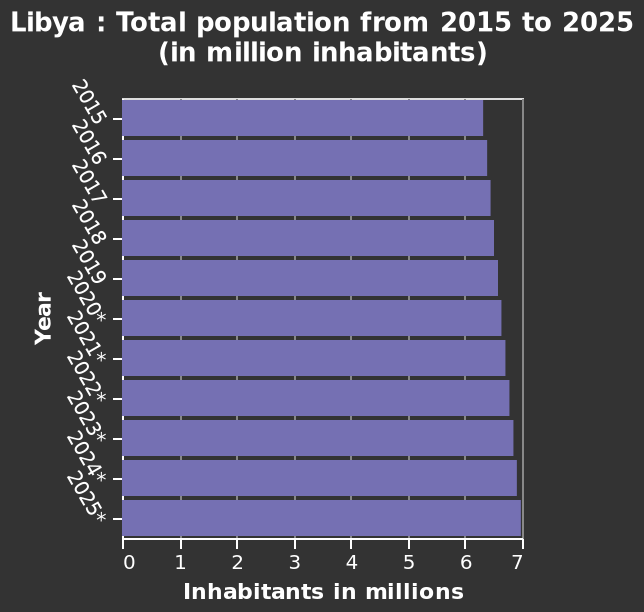<image>
please enumerates aspects of the construction of the chart Here a is a bar chart called Libya : Total population from 2015 to 2025 (in million inhabitants). Along the y-axis, Year is defined along a categorical scale starting with 2015 and ending with 2025*. The x-axis plots Inhabitants in millions along a linear scale of range 0 to 7. Is here a line graph called Libya : Total population from 2015 to 2025 (in million inhabitants)? No.Here a is a bar chart called Libya : Total population from 2015 to 2025 (in million inhabitants). Along the y-axis, Year is defined along a categorical scale starting with 2015 and ending with 2025*. The x-axis plots Inhabitants in millions along a linear scale of range 0 to 7. 